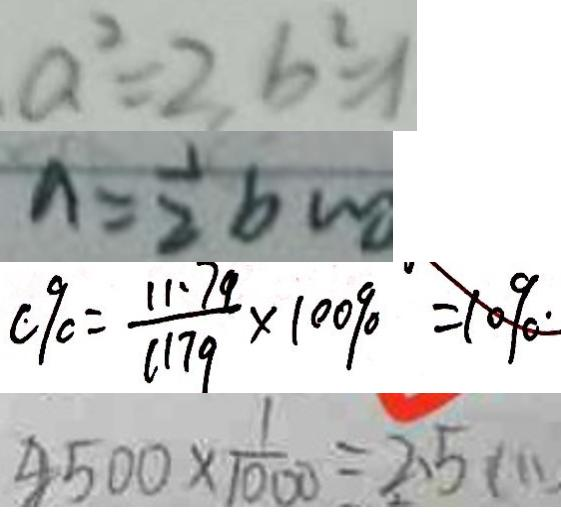Convert formula to latex. <formula><loc_0><loc_0><loc_500><loc_500>a ^ { 2 } = 2 , b ^ { 2 } = 1 
 n = \frac { 1 } { 2 } b m 
 c 9 0 = \frac { 1 1 . 7 9 } { 1 1 7 9 } \times 1 0 0 9 0 = 1 0 9 0 . 
 4 5 0 0 \times \frac { 1 } { 1 0 0 0 } = 2 . 5 ( m )</formula> 